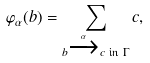Convert formula to latex. <formula><loc_0><loc_0><loc_500><loc_500>\varphi _ { \alpha } ( b ) = \sum _ { b \xrightarrow { \alpha } c \text { in } \Gamma } c ,</formula> 